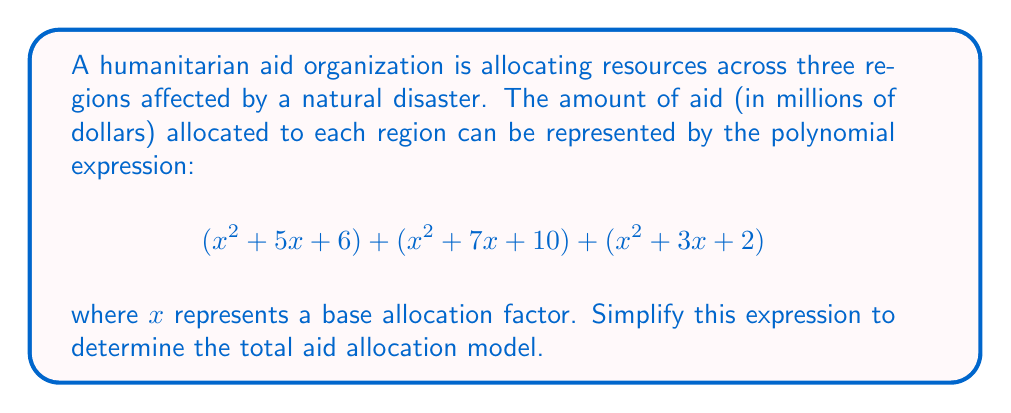Can you answer this question? To simplify this expression, we need to combine like terms:

1. Combine the $x^2$ terms:
   $$(x^2 + x^2 + x^2) = 3x^2$$

2. Combine the $x$ terms:
   $$(5x + 7x + 3x) = 15x$$

3. Combine the constant terms:
   $$(6 + 10 + 2) = 18$$

4. Write the simplified polynomial:
   $$3x^2 + 15x + 18$$

5. Check if the polynomial can be factored:
   The polynomial $3x^2 + 15x + 18$ can be factored as:
   $$3(x^2 + 5x + 6)$$

6. Further factor the expression inside the parentheses:
   $$3(x + 2)(x + 3)$$

Thus, the simplified expression representing the total aid allocation model is $3(x + 2)(x + 3)$.
Answer: $3(x + 2)(x + 3)$ 